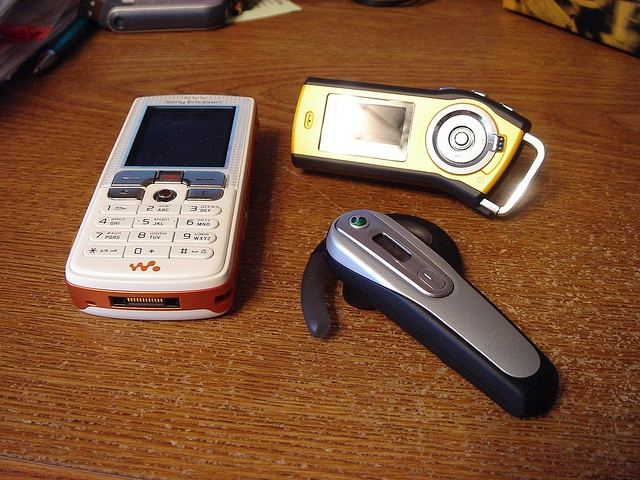Describe the objects in this image and their specific colors. I can see a cell phone in gray, lightgray, black, darkgray, and maroon tones in this image. 